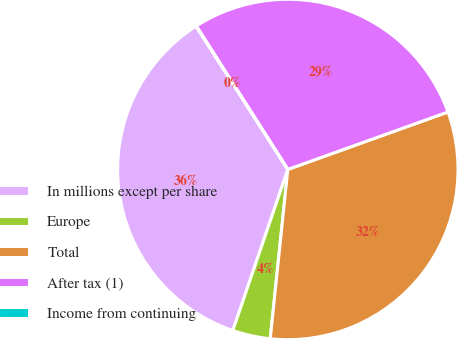Convert chart to OTSL. <chart><loc_0><loc_0><loc_500><loc_500><pie_chart><fcel>In millions except per share<fcel>Europe<fcel>Total<fcel>After tax (1)<fcel>Income from continuing<nl><fcel>35.7%<fcel>3.59%<fcel>32.13%<fcel>28.56%<fcel>0.02%<nl></chart> 